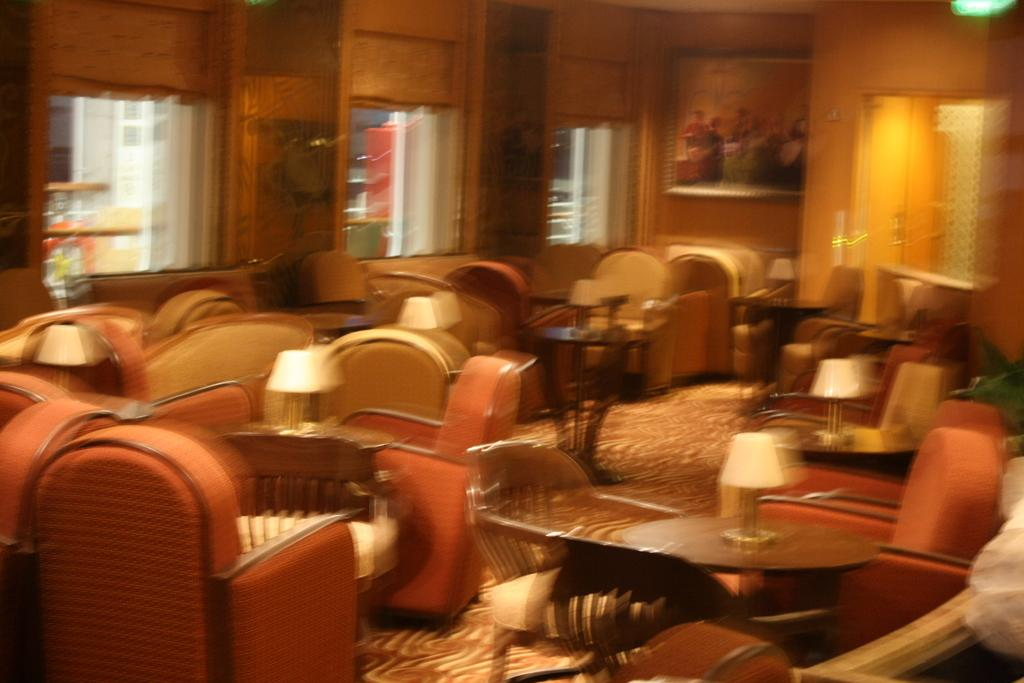What type of furniture is present in the image? There are chairs and tables in the image. What can be seen through the windows in the image? The presence of windows suggests that there might be a view or outdoor scenery visible, but the specifics are not mentioned in the facts. Where is the painting located in the image? The painting is in the top right of the image. What is the purpose of the grandmother in the image? There is no mention of a grandmother in the image, so it is not possible to determine her purpose. How many bits are visible in the image? There is no reference to any "bits" in the image, so it is not possible to determine their presence or quantity. 